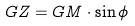Convert formula to latex. <formula><loc_0><loc_0><loc_500><loc_500>G Z = G M \cdot \sin \phi</formula> 